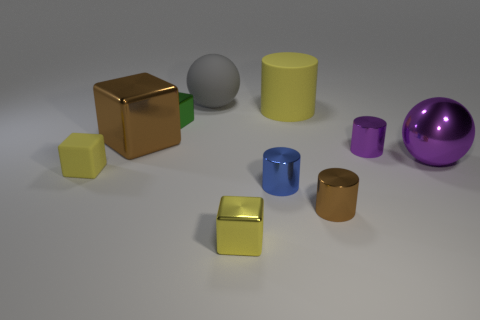Which object in the image reflects the most light? The purple sphere on the right reflects the most light, indicating it has a highly polished, possibly metallic surface. 